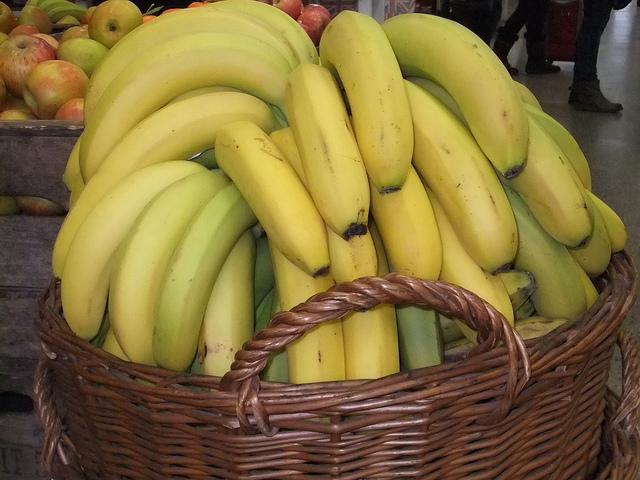What pome fruits are shown here? banana 